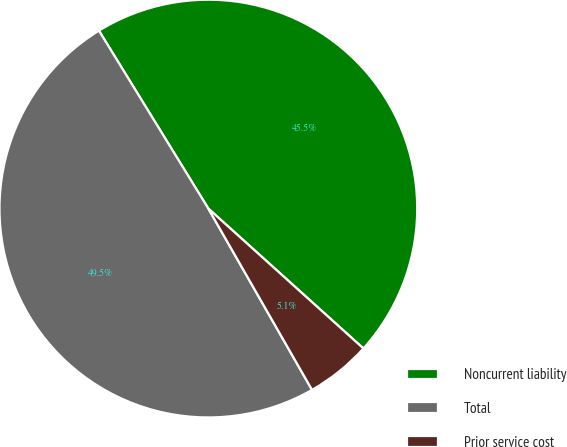Convert chart to OTSL. <chart><loc_0><loc_0><loc_500><loc_500><pie_chart><fcel>Noncurrent liability<fcel>Total<fcel>Prior service cost<nl><fcel>45.45%<fcel>49.49%<fcel>5.05%<nl></chart> 